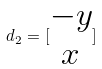<formula> <loc_0><loc_0><loc_500><loc_500>d _ { 2 } = [ \begin{matrix} - y \\ x \\ \end{matrix} ]</formula> 